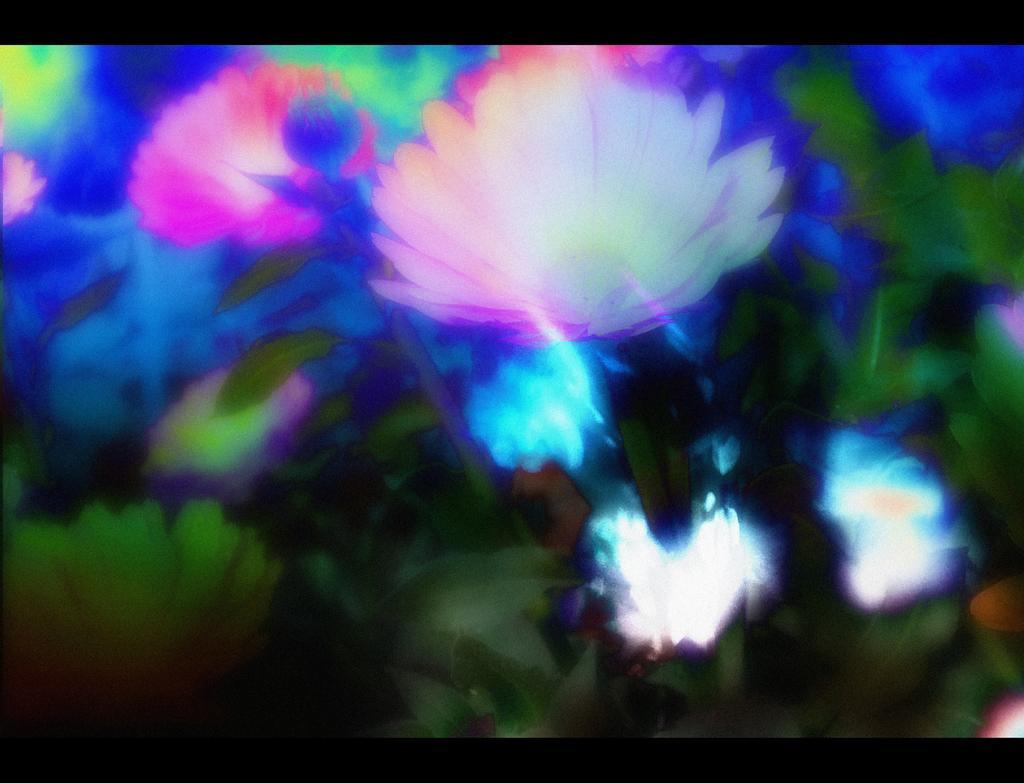Could you give a brief overview of what you see in this image? It is an edited image in this there are beautiful flowers and leaves. 